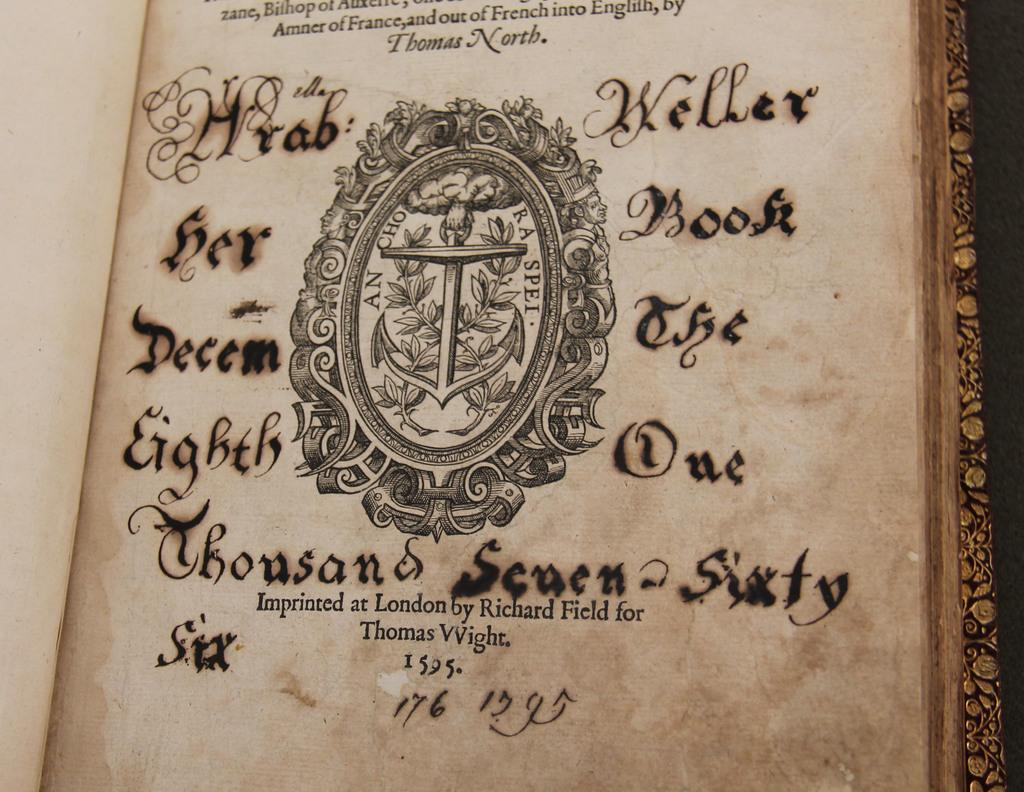Provide a one-sentence caption for the provided image. The inside cover of a book imprinted at London by Richard Field for Thomas Wight. 